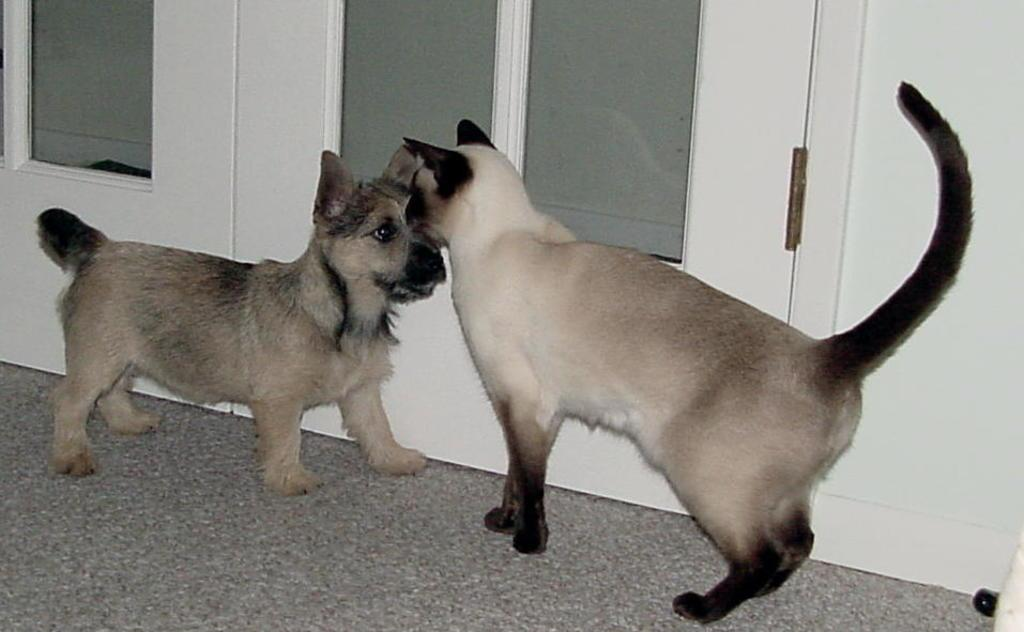What is the color of the wall in the image? The wall in the image is white. What can be found on the wall in the image? There are doors in the image. What animals are present in the image? There is a cat and a dog in the image. What type of stone is the cat sitting on in the image? There is no stone present in the image; the cat is sitting on the floor or ground. 